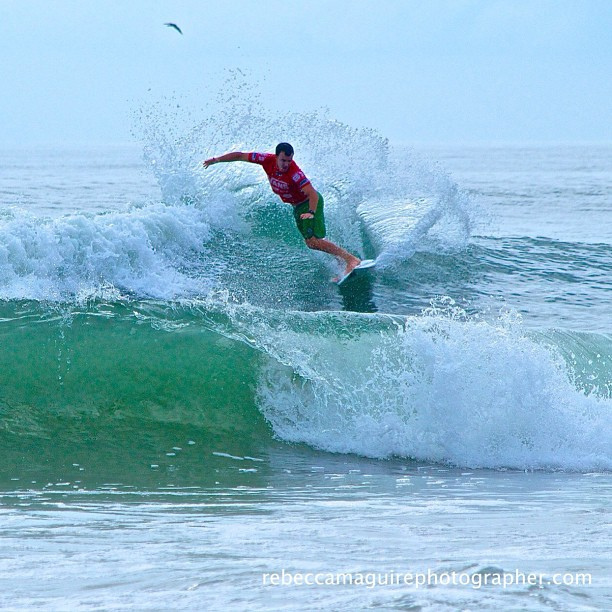Identify the text displayed in this image. rebeccamaguiephotographer.com c 